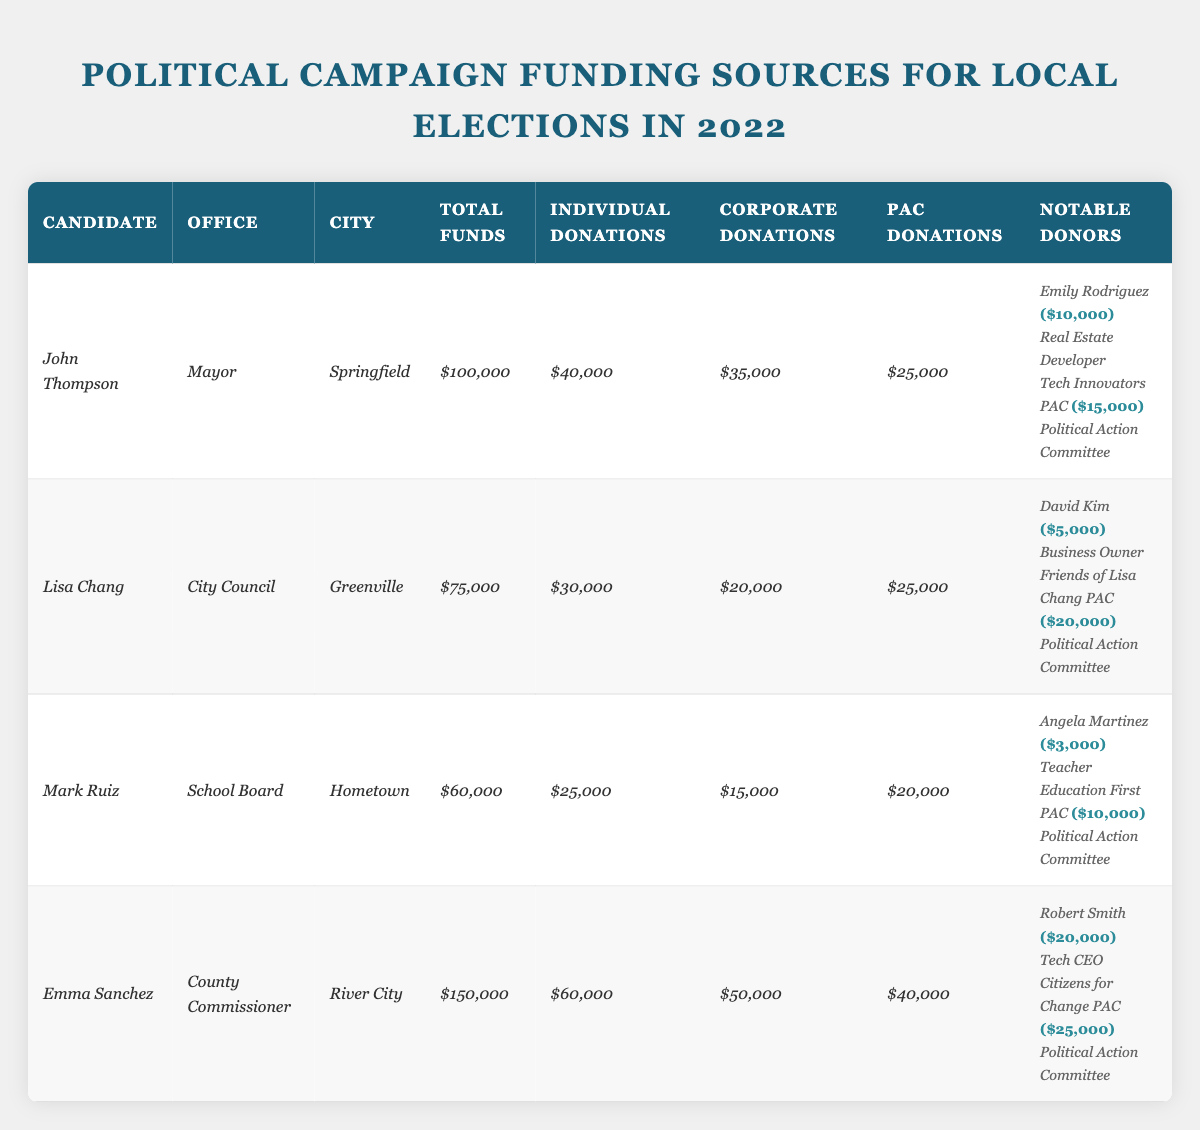What is the total amount of funds raised by Emma Sanchez? According to the table, Emma Sanchez raised a total of $150,000. This figure is specified under the "Total Funds" column for her entry.
Answer: $150,000 Which candidate received the highest amount from individual donations? By comparing the individual donations for each candidate, John Thompson received $40,000, Emma Sanchez received $60,000, Lisa Chang received $30,000, and Mark Ruiz received $25,000. Emma Sanchez has the highest amount in this category.
Answer: Emma Sanchez How much more did corporate donations contribute to John Thompson compared to Mark Ruiz? John Thompson received $35,000 from corporate donations, while Mark Ruiz received $15,000. To find the difference, we subtract Mark Ruiz's contributions from John Thompson's: $35,000 - $15,000 = $20,000.
Answer: $20,000 Which candidate has the lowest total funds, and what is that amount? Looking at the "Total Funds" column, Mark Ruiz has the lowest amount with $60,000, compared to the other candidates who raised more.
Answer: Mark Ruiz; $60,000 Did any candidate receive more than 50% of their total funds from individual donations? To find out, we compare the individual donations to total funds for each candidate. For Emma Sanchez: $60,000/$150,000 = 0.4 (40%), for John Thompson: $40,000/$100,000 = 0.4 (40%), Lisa Chang: $30,000/$75,000 = 0.4 (40%), and Mark Ruiz: $25,000/$60,000 = 0.4167 (about 41.67%). None met or exceeded 50%.
Answer: No What is the combined amount received from Political Action Committees (PAC) for all candidates? Summing the PAC contributions for all candidates: John Thompson ($25,000) + Lisa Chang ($25,000) + Mark Ruiz ($20,000) + Emma Sanchez ($40,000) = $110,000.
Answer: $110,000 Which candidate had the most notable donor contributions, and what was the total? John Thompson's notable donors contributed a total of $25,000 ($10,000 from Emily Rodriguez and $15,000 from Tech Innovators PAC). Emma Sanchez's donors contributed a total of $45,000 ($20,000 from Robert Smith and $25,000 from Citizens for Change PAC). Therefore, Emma Sanchez had the highest total.
Answer: Emma Sanchez; $45,000 Is there any candidate supported by a donor with a significant occupation, such as a "Tech CEO"? Yes, Emma Sanchez has a notable donor, Robert Smith, who is a "Tech CEO." This occupation is listed alongside his donation amount of $20,000.
Answer: Yes 